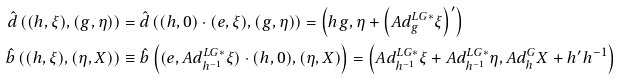Convert formula to latex. <formula><loc_0><loc_0><loc_500><loc_500>\hat { d } \left ( ( h , \xi ) , \left ( g , \eta \right ) \right ) & = \hat { d } \left ( ( h , 0 ) \cdot ( e , \xi ) , \left ( g , \eta \right ) \right ) = \left ( h g , \eta + \left ( A d _ { g } ^ { L G \ast } \xi \right ) ^ { \prime } \right ) \\ \hat { b } \left ( ( h , \xi ) , \left ( \eta , X \right ) \right ) & \equiv \hat { b } \left ( ( e , A d _ { h ^ { - 1 } } ^ { L G \ast } \xi ) \cdot ( h , 0 ) , \left ( \eta , X \right ) \right ) = \left ( A d _ { h ^ { - 1 } } ^ { L G \ast } \xi + A d _ { h ^ { - 1 } } ^ { L G \ast } \eta , A d _ { h } ^ { G } X + h ^ { \prime } h ^ { - 1 } \right )</formula> 